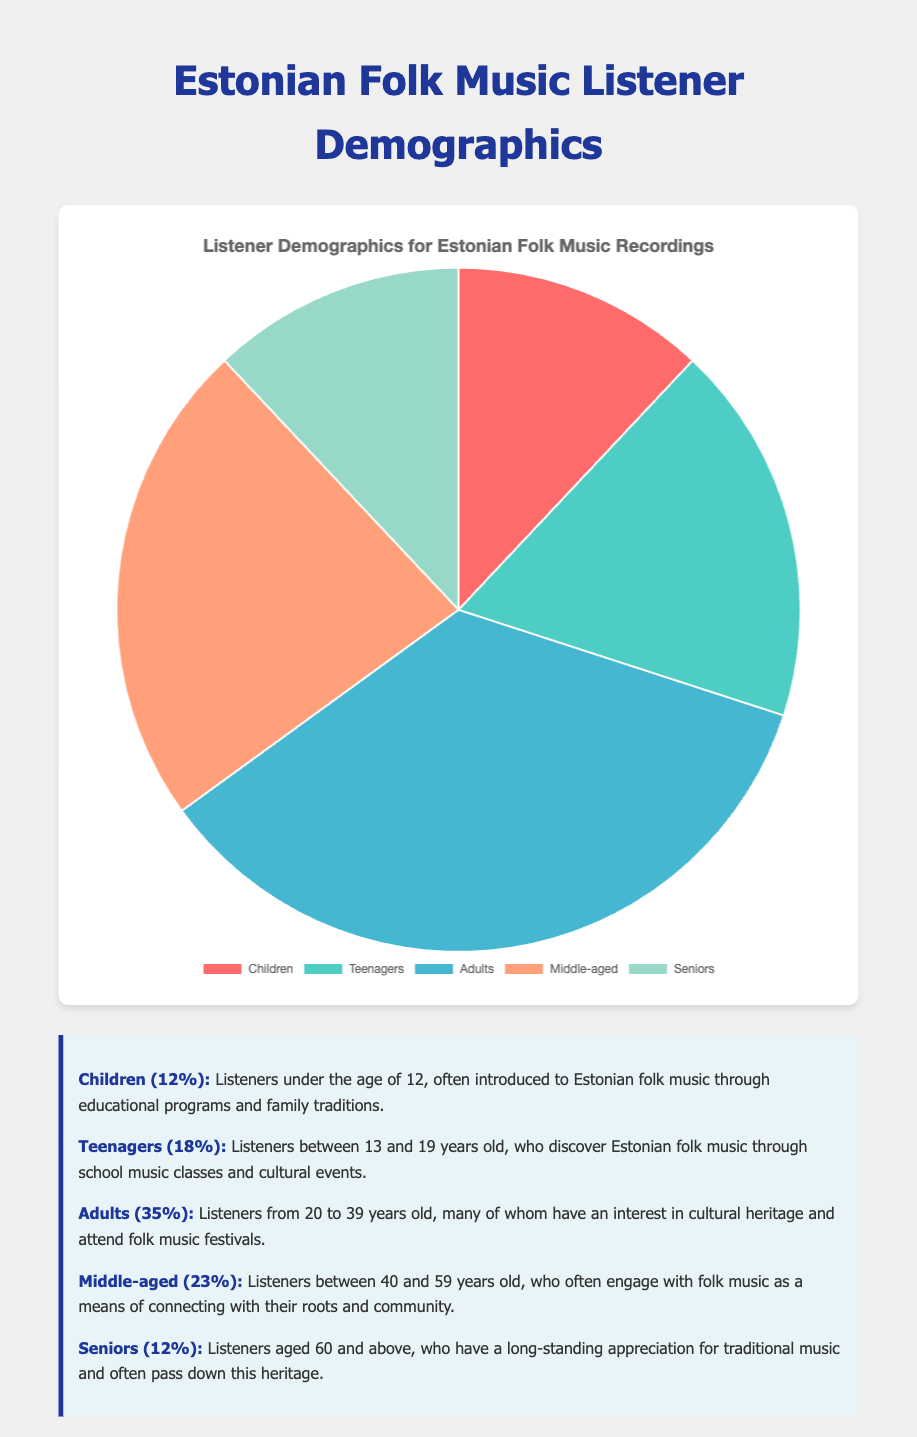Which age group has the highest percentage of listeners? From the pie chart, the largest segment corresponds to the age group "Adults" with a percentage of 35%.
Answer: Adults What is the combined percentage of listeners who are either Children or Seniors? The percentage for Children is 12%, and for Seniors, it is also 12%. Adding these together, 12 + 12 = 24%.
Answer: 24% Which age group has more listeners, Teenagers or Middle-aged? From the pie chart, Teenagers have 18% while Middle-aged has 23%. Since 23 is greater than 18, Middle-aged has more listeners.
Answer: Middle-aged How much greater is the percentage of Adults compared to Children? Adults have a percentage of 35% and Children have 12%. To find the difference, we subtract 12 from 35, which gives us 35 - 12 = 23%.
Answer: 23% What is the difference between the total percentage of listeners above the age of 19 and those below 20? The percentages for listeners above 19 are: Adults (35%) and Middle-aged (23%) and Seniors (12%). Summing these gives 35 + 23 + 12 = 70%. The percentages for listeners below 20 are: Children (12%) and Teenagers (18%), summing these gives 12 + 18 = 30%. The difference is 70 - 30 = 40%.
Answer: 40% Which age groups have the same percentage of listeners? From the pie chart, it is shown that Children and Seniors both have a percentage of 12%.
Answer: Children and Seniors What is the average percentage of listeners for all given age groups? The percentages are 12, 18, 35, 23, and 12. Summing these gives 12 + 18 + 35 + 23 + 12 = 100. The number of groups is 5. The average is 100 / 5 = 20%.
Answer: 20% Identify the color attributed to the Middle-aged group. In the pie chart, the color representing Middle-aged listeners is the fourth segment, which visually corresponds to a light orange shade.
Answer: Light orange What is the total percentage of listeners who are either Teenagers or Adults? The percentages for Teenagers and Adults are 18% and 35%, respectively. Adding these, we get 18 + 35 = 53%.
Answer: 53% Compare the percentages between the two smallest age groups and explain their significance. The two smallest age groups are Children and Seniors, both with 12%. Their combined percentage is 24%, indicating that listeners under 12 and above 60 make up nearly a quarter of the audience, reflecting a strong, sustained interest across generations.
Answer: 24% 